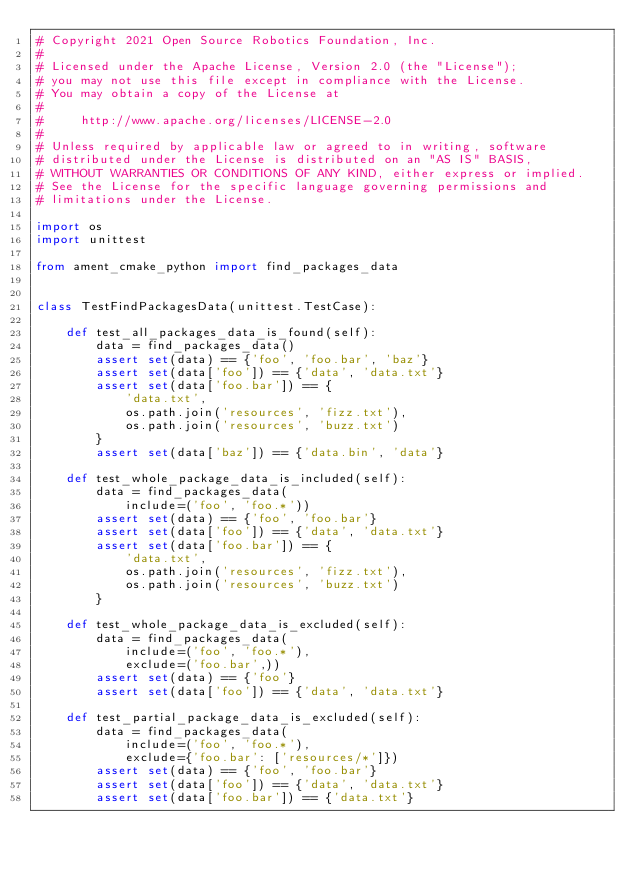<code> <loc_0><loc_0><loc_500><loc_500><_Python_># Copyright 2021 Open Source Robotics Foundation, Inc.
#
# Licensed under the Apache License, Version 2.0 (the "License");
# you may not use this file except in compliance with the License.
# You may obtain a copy of the License at
#
#     http://www.apache.org/licenses/LICENSE-2.0
#
# Unless required by applicable law or agreed to in writing, software
# distributed under the License is distributed on an "AS IS" BASIS,
# WITHOUT WARRANTIES OR CONDITIONS OF ANY KIND, either express or implied.
# See the License for the specific language governing permissions and
# limitations under the License.

import os
import unittest

from ament_cmake_python import find_packages_data


class TestFindPackagesData(unittest.TestCase):

    def test_all_packages_data_is_found(self):
        data = find_packages_data()
        assert set(data) == {'foo', 'foo.bar', 'baz'}
        assert set(data['foo']) == {'data', 'data.txt'}
        assert set(data['foo.bar']) == {
            'data.txt',
            os.path.join('resources', 'fizz.txt'),
            os.path.join('resources', 'buzz.txt')
        }
        assert set(data['baz']) == {'data.bin', 'data'}

    def test_whole_package_data_is_included(self):
        data = find_packages_data(
            include=('foo', 'foo.*'))
        assert set(data) == {'foo', 'foo.bar'}
        assert set(data['foo']) == {'data', 'data.txt'}
        assert set(data['foo.bar']) == {
            'data.txt',
            os.path.join('resources', 'fizz.txt'),
            os.path.join('resources', 'buzz.txt')
        }

    def test_whole_package_data_is_excluded(self):
        data = find_packages_data(
            include=('foo', 'foo.*'),
            exclude=('foo.bar',))
        assert set(data) == {'foo'}
        assert set(data['foo']) == {'data', 'data.txt'}

    def test_partial_package_data_is_excluded(self):
        data = find_packages_data(
            include=('foo', 'foo.*'),
            exclude={'foo.bar': ['resources/*']})
        assert set(data) == {'foo', 'foo.bar'}
        assert set(data['foo']) == {'data', 'data.txt'}
        assert set(data['foo.bar']) == {'data.txt'}
</code> 